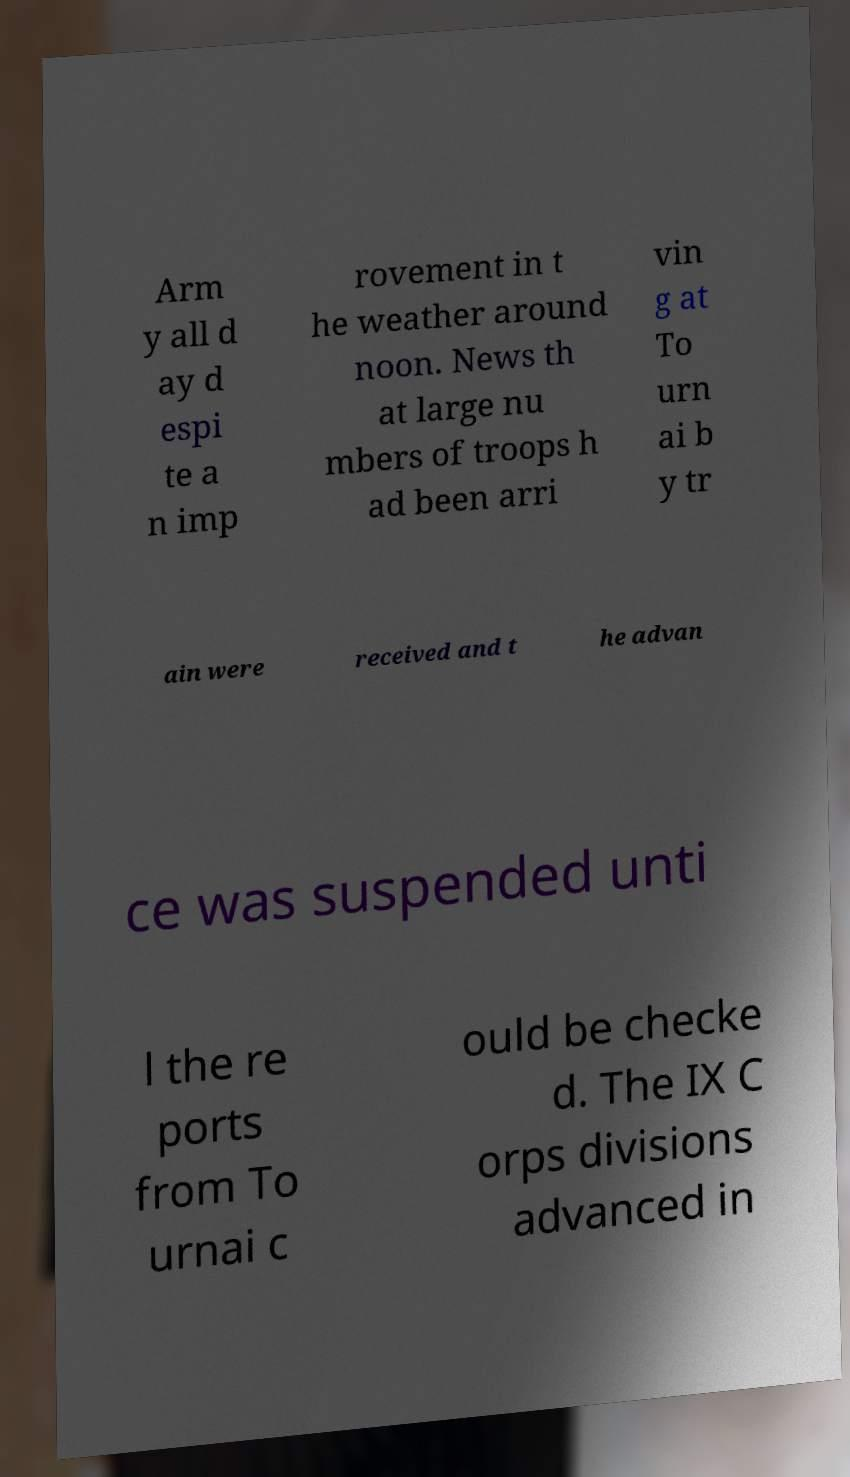Could you extract and type out the text from this image? Arm y all d ay d espi te a n imp rovement in t he weather around noon. News th at large nu mbers of troops h ad been arri vin g at To urn ai b y tr ain were received and t he advan ce was suspended unti l the re ports from To urnai c ould be checke d. The IX C orps divisions advanced in 